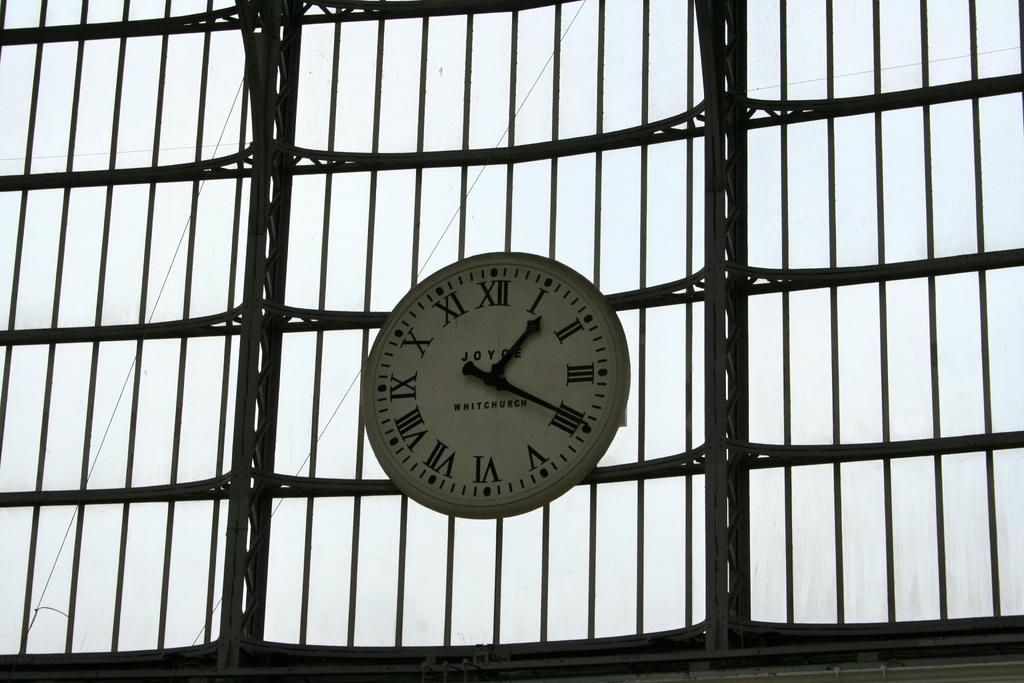<image>
Write a terse but informative summary of the picture. a clock that has many roman numerals on it 